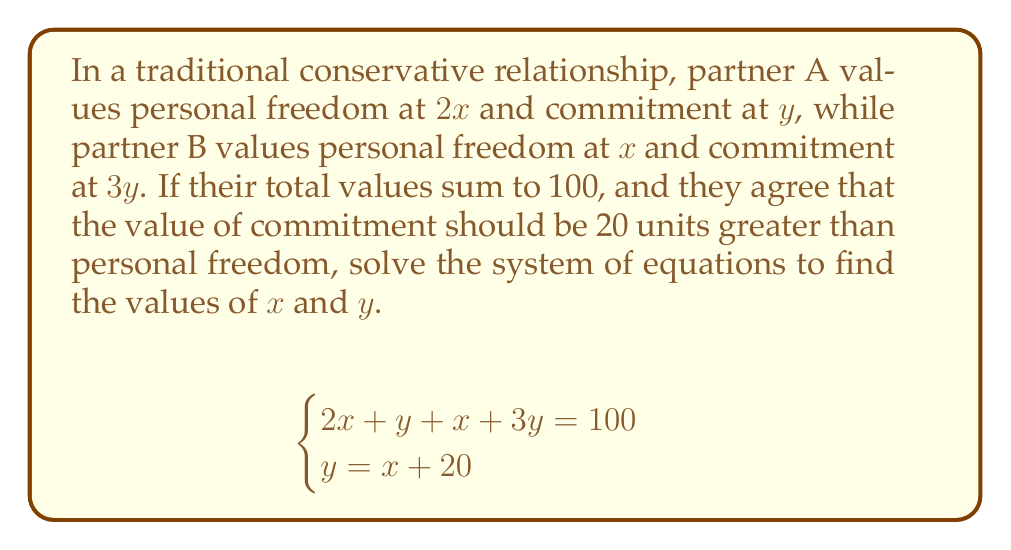Solve this math problem. Let's solve this system of equations step by step:

1) First, we have two equations:
   $$2x + y + x + 3y = 100$$
   $$y = x + 20$$

2) Simplify the first equation:
   $$3x + 4y = 100$$

3) Substitute $y = x + 20$ into the simplified equation:
   $$3x + 4(x + 20) = 100$$

4) Distribute the 4:
   $$3x + 4x + 80 = 100$$

5) Combine like terms:
   $$7x + 80 = 100$$

6) Subtract 80 from both sides:
   $$7x = 20$$

7) Divide both sides by 7:
   $$x = \frac{20}{7} \approx 2.86$$

8) Now that we know $x$, we can find $y$ using the second equation:
   $$y = x + 20 = \frac{20}{7} + 20 = \frac{20}{7} + \frac{140}{7} = \frac{160}{7} \approx 22.86$$

Therefore, personal freedom ($x$) is valued at approximately 2.86 units, and commitment ($y$) is valued at approximately 22.86 units.
Answer: $x \approx 2.86$, $y \approx 22.86$ 